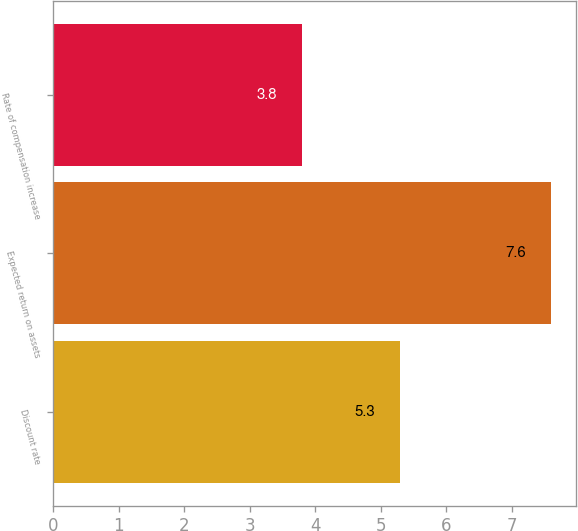Convert chart. <chart><loc_0><loc_0><loc_500><loc_500><bar_chart><fcel>Discount rate<fcel>Expected return on assets<fcel>Rate of compensation increase<nl><fcel>5.3<fcel>7.6<fcel>3.8<nl></chart> 